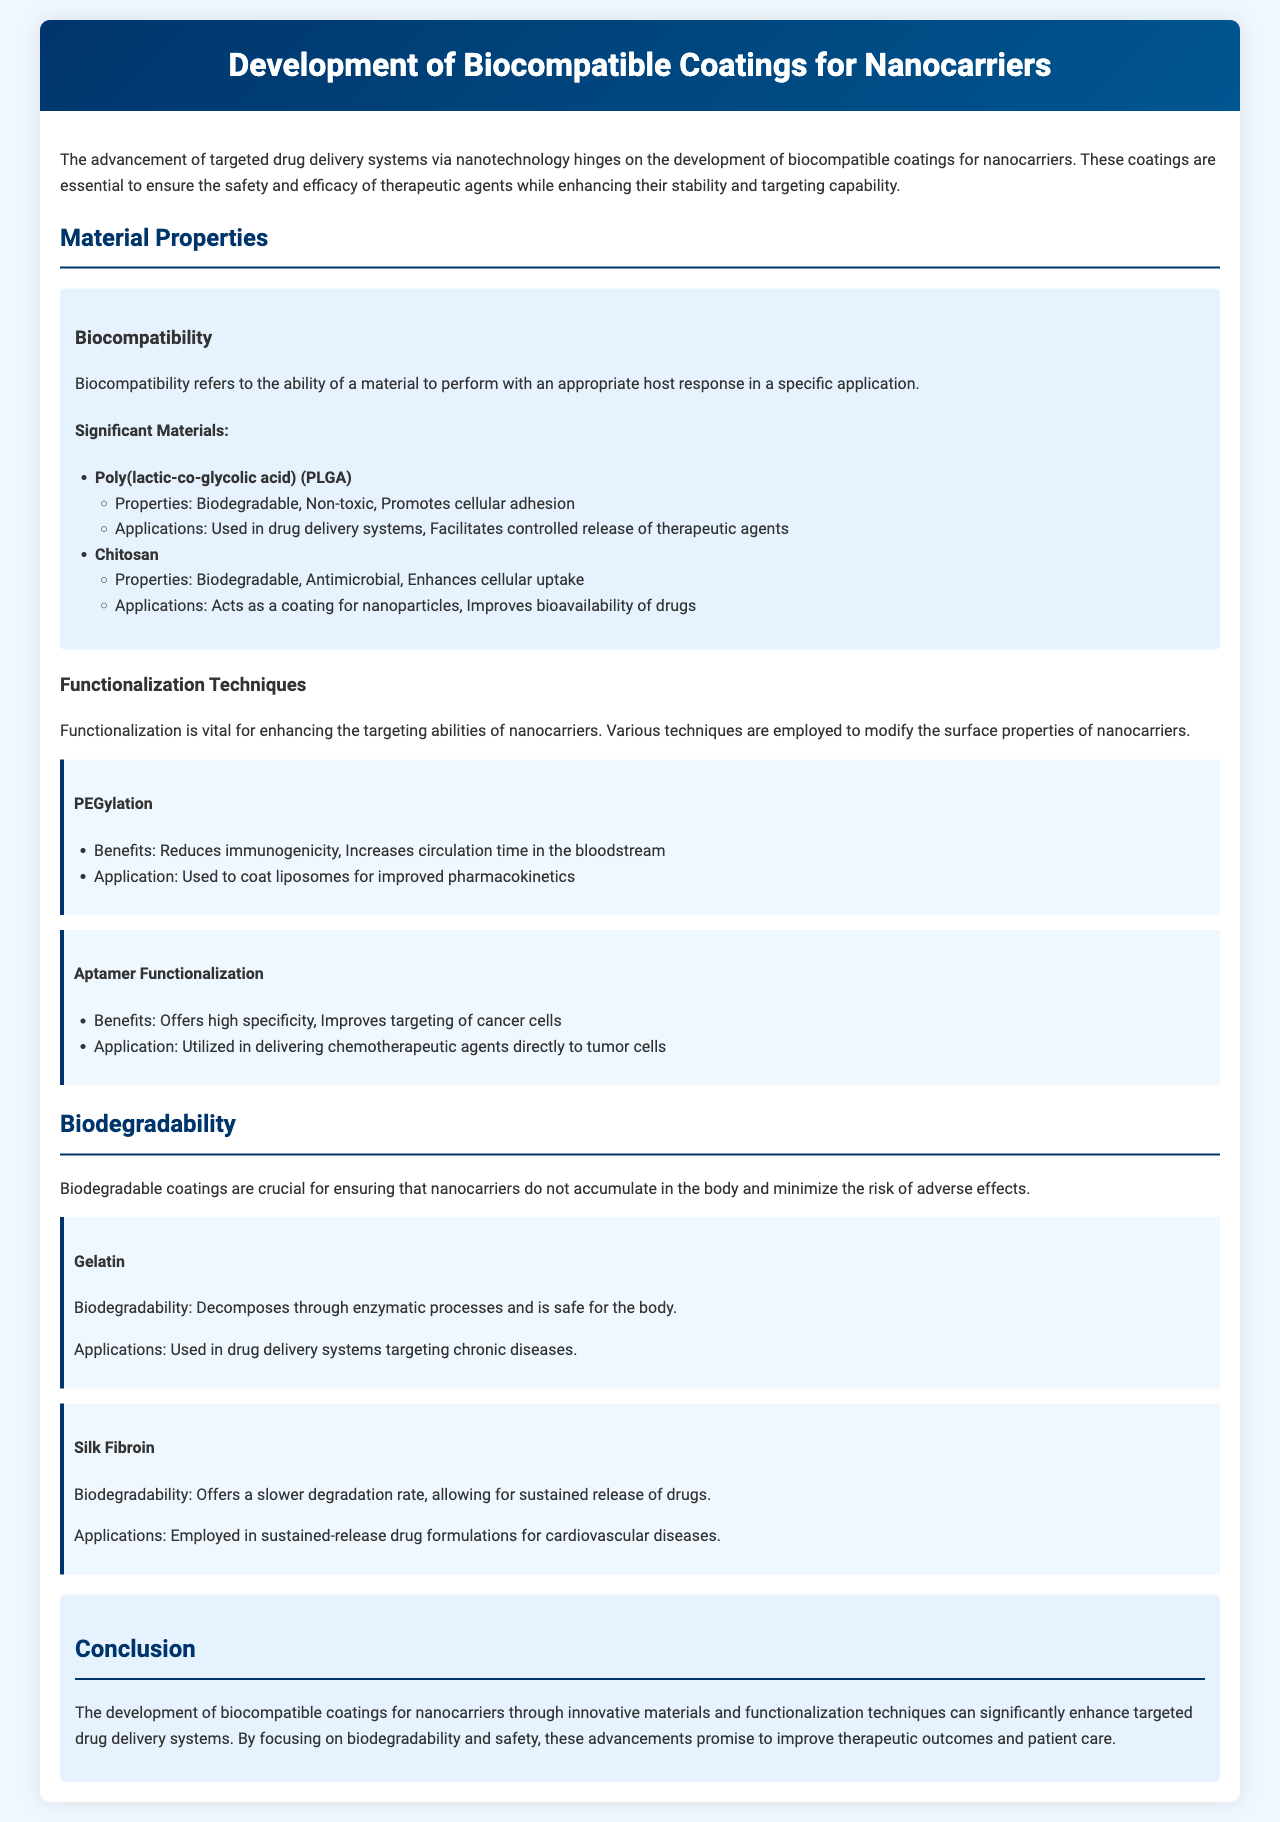what is biocompatibility? Biocompatibility refers to the ability of a material to perform with an appropriate host response in a specific application.
Answer: ability to perform with an appropriate host response name a significant material used in drug delivery systems. The document lists several significant materials, and one of them is Poly(lactic-co-glycolic acid).
Answer: Poly(lactic-co-glycolic acid) which technique reduces immunogenicity? PEGylation is mentioned as a technique that reduces immunogenicity.
Answer: PEGylation what is the biodegradability property of Gelatin? Gelatin decomposes through enzymatic processes and is safe for the body.
Answer: decomposes through enzymatic processes what is one benefit of Aptamer Functionalization? One benefit provided in the document is that it offers high specificity.
Answer: high specificity in which application is Silk Fibroin used? Silk Fibroin is employed in sustained-release drug formulations for cardiovascular diseases.
Answer: sustained-release drug formulations for cardiovascular diseases how does PEGylation affect circulation time? The document states that PEGylation increases circulation time in the bloodstream.
Answer: increases circulation time what is a primary focus of the document? The primary focus of the document is the development of biocompatible coatings for nanocarriers.
Answer: development of biocompatible coatings for nanocarriers 